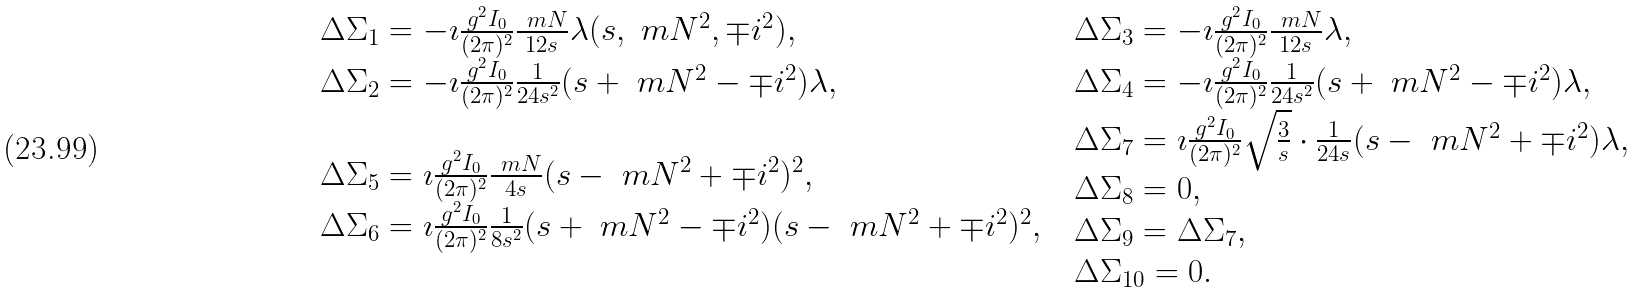Convert formula to latex. <formula><loc_0><loc_0><loc_500><loc_500>\begin{array} { l l } \begin{array} { l } \Delta \Sigma _ { 1 } = - \imath \frac { g ^ { 2 } I _ { 0 } } { ( 2 \pi ) ^ { 2 } } \frac { \ m N } { 1 2 s } \lambda ( s , \ m N ^ { 2 } , \mp i ^ { 2 } ) , \\ \Delta \Sigma _ { 2 } = - \imath \frac { g ^ { 2 } I _ { 0 } } { ( 2 \pi ) ^ { 2 } } \frac { 1 } { 2 4 s ^ { 2 } } ( s + \ m N ^ { 2 } - \mp i ^ { 2 } ) \lambda , \end{array} & \begin{array} { l } \Delta \Sigma _ { 3 } = - \imath \frac { g ^ { 2 } I _ { 0 } } { ( 2 \pi ) ^ { 2 } } \frac { \ m N } { 1 2 s } \lambda , \\ \Delta \Sigma _ { 4 } = - \imath \frac { g ^ { 2 } I _ { 0 } } { ( 2 \pi ) ^ { 2 } } \frac { 1 } { 2 4 s ^ { 2 } } ( s + \ m N ^ { 2 } - \mp i ^ { 2 } ) \lambda , \end{array} \\ \begin{array} { l } \Delta \Sigma _ { 5 } = \imath \frac { g ^ { 2 } I _ { 0 } } { ( 2 \pi ) ^ { 2 } } \frac { \ m N } { 4 s } ( s - \ m N ^ { 2 } + \mp i ^ { 2 } ) ^ { 2 } , \\ \Delta \Sigma _ { 6 } = \imath \frac { g ^ { 2 } I _ { 0 } } { ( 2 \pi ) ^ { 2 } } \frac { 1 } { 8 s ^ { 2 } } ( s + \ m N ^ { 2 } - \mp i ^ { 2 } ) ( s - \ m N ^ { 2 } + \mp i ^ { 2 } ) ^ { 2 } , \end{array} & \begin{array} { l } \Delta \Sigma _ { 7 } = \imath \frac { g ^ { 2 } I _ { 0 } } { ( 2 \pi ) ^ { 2 } } \sqrt { \frac { 3 } { s } } \cdot \frac { 1 } { 2 4 s } ( s - \ m N ^ { 2 } + \mp i ^ { 2 } ) \lambda , \\ \Delta \Sigma _ { 8 } = 0 , \\ \Delta \Sigma _ { 9 } = \Delta \Sigma _ { 7 } , \\ \Delta \Sigma _ { 1 0 } = 0 . \end{array} \end{array}</formula> 